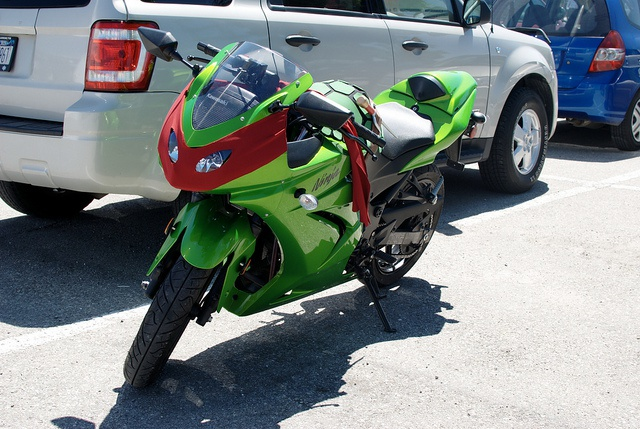Describe the objects in this image and their specific colors. I can see motorcycle in black, darkgreen, maroon, and gray tones, car in black, darkgray, gray, and lightgray tones, and car in black, navy, and blue tones in this image. 